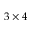<formula> <loc_0><loc_0><loc_500><loc_500>3 \times 4</formula> 